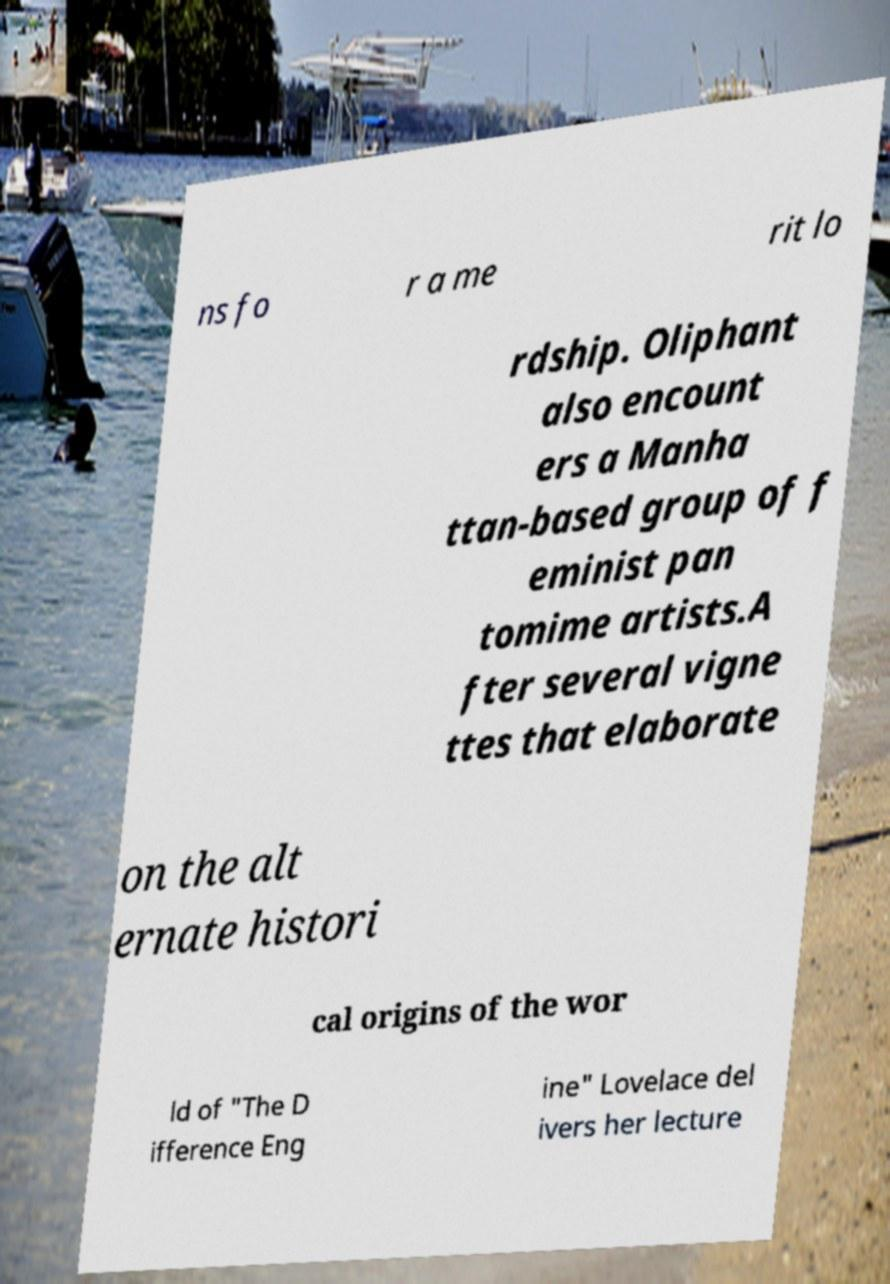Can you accurately transcribe the text from the provided image for me? ns fo r a me rit lo rdship. Oliphant also encount ers a Manha ttan-based group of f eminist pan tomime artists.A fter several vigne ttes that elaborate on the alt ernate histori cal origins of the wor ld of "The D ifference Eng ine" Lovelace del ivers her lecture 